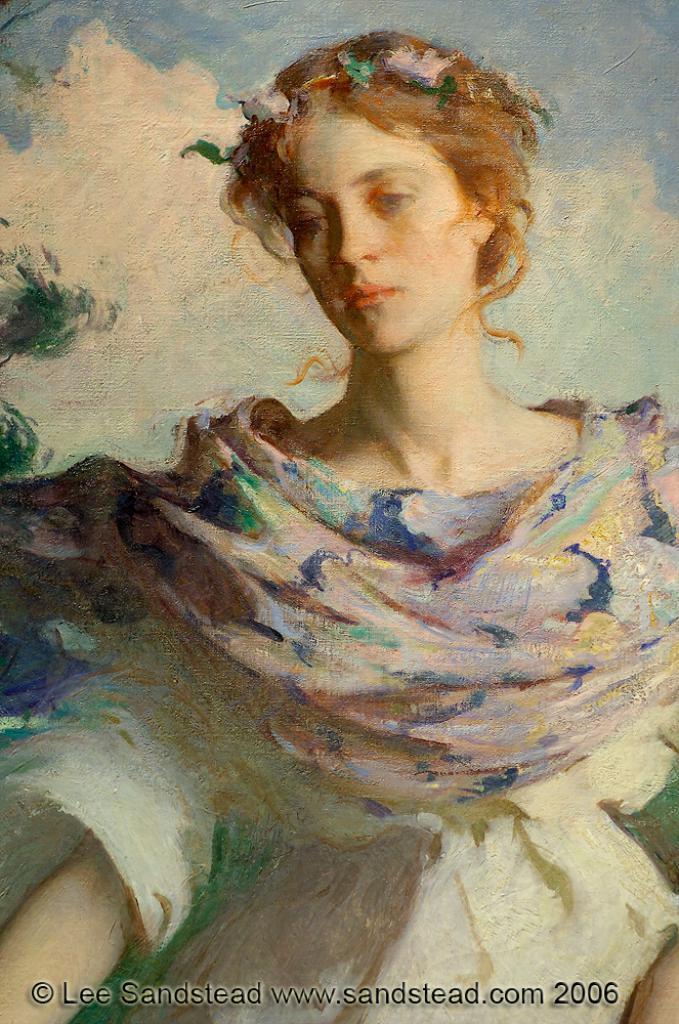How would you summarize this image in a sentence or two? In this picture we can see a painting. 